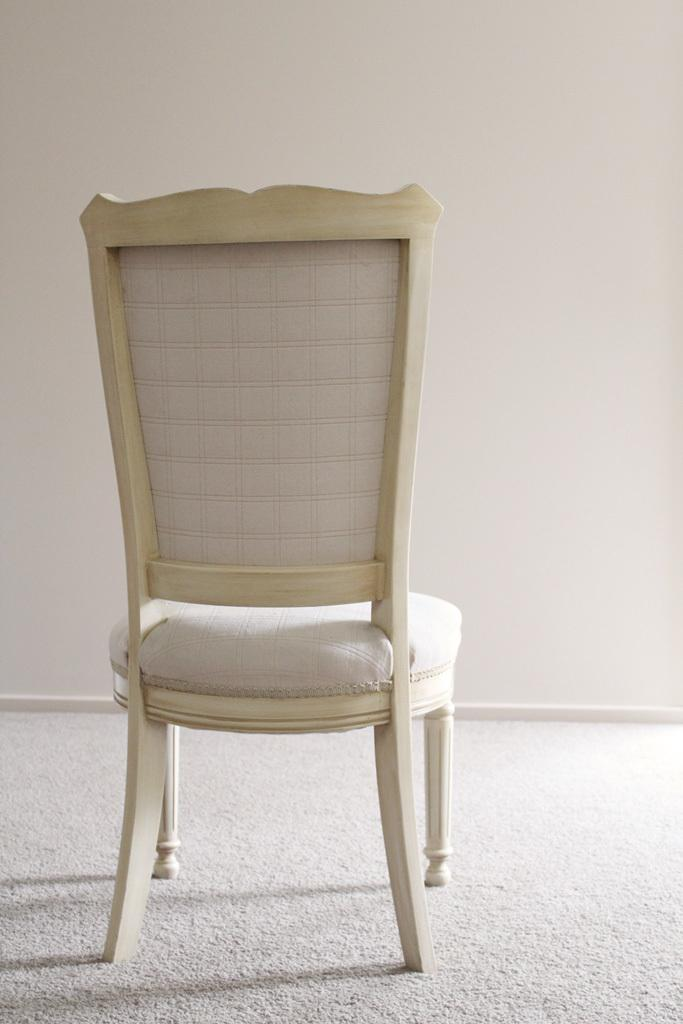What type of furniture is in the image? There is a chair in the image. What is the chair resting on? The chair is on a surface. What can be seen behind the chair in the image? There is a wall in the background of the image. What type of paper is being used to decorate the cemetery in the image? There is no cemetery or paper present in the image; it features a chair on a surface with a wall in the background. 